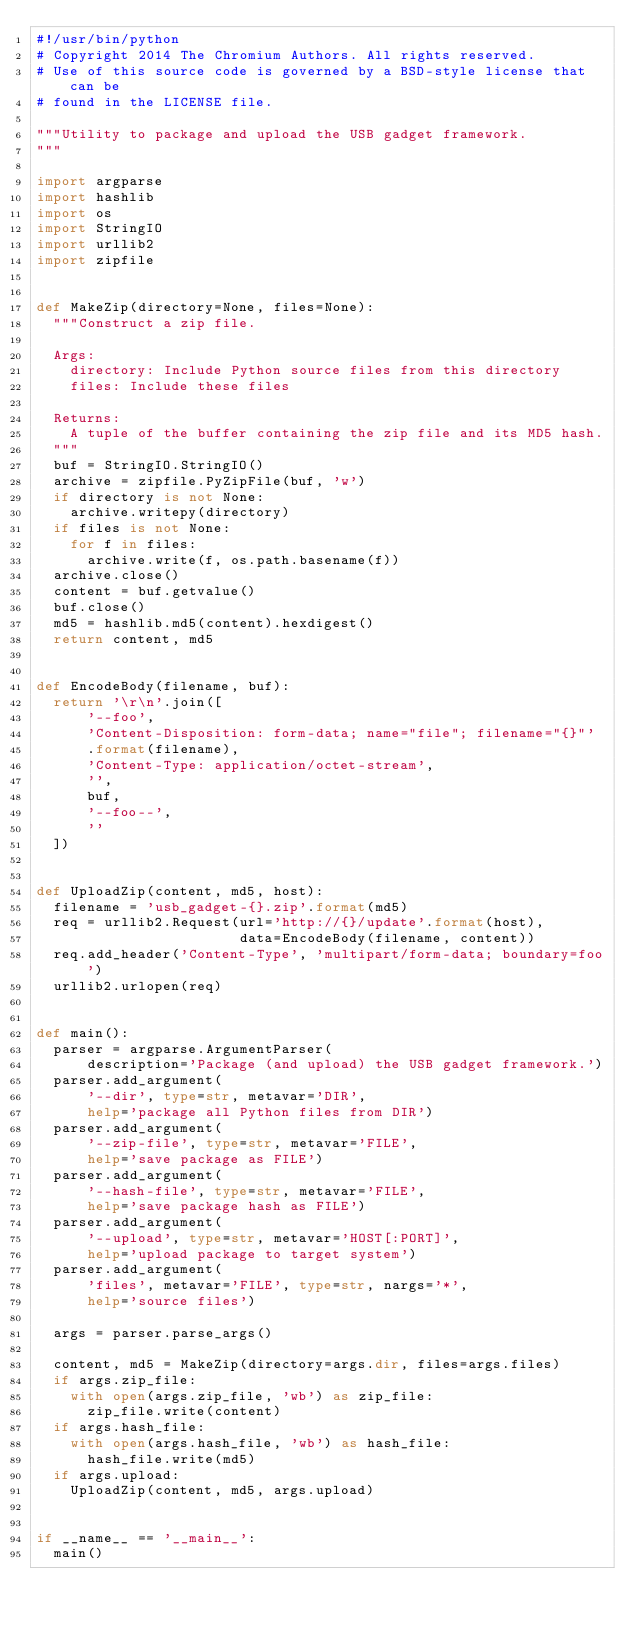Convert code to text. <code><loc_0><loc_0><loc_500><loc_500><_Python_>#!/usr/bin/python
# Copyright 2014 The Chromium Authors. All rights reserved.
# Use of this source code is governed by a BSD-style license that can be
# found in the LICENSE file.

"""Utility to package and upload the USB gadget framework.
"""

import argparse
import hashlib
import os
import StringIO
import urllib2
import zipfile


def MakeZip(directory=None, files=None):
  """Construct a zip file.

  Args:
    directory: Include Python source files from this directory
    files: Include these files

  Returns:
    A tuple of the buffer containing the zip file and its MD5 hash.
  """
  buf = StringIO.StringIO()
  archive = zipfile.PyZipFile(buf, 'w')
  if directory is not None:
    archive.writepy(directory)
  if files is not None:
    for f in files:
      archive.write(f, os.path.basename(f))
  archive.close()
  content = buf.getvalue()
  buf.close()
  md5 = hashlib.md5(content).hexdigest()
  return content, md5


def EncodeBody(filename, buf):
  return '\r\n'.join([
      '--foo',
      'Content-Disposition: form-data; name="file"; filename="{}"'
      .format(filename),
      'Content-Type: application/octet-stream',
      '',
      buf,
      '--foo--',
      ''
  ])


def UploadZip(content, md5, host):
  filename = 'usb_gadget-{}.zip'.format(md5)
  req = urllib2.Request(url='http://{}/update'.format(host),
                        data=EncodeBody(filename, content))
  req.add_header('Content-Type', 'multipart/form-data; boundary=foo')
  urllib2.urlopen(req)


def main():
  parser = argparse.ArgumentParser(
      description='Package (and upload) the USB gadget framework.')
  parser.add_argument(
      '--dir', type=str, metavar='DIR',
      help='package all Python files from DIR')
  parser.add_argument(
      '--zip-file', type=str, metavar='FILE',
      help='save package as FILE')
  parser.add_argument(
      '--hash-file', type=str, metavar='FILE',
      help='save package hash as FILE')
  parser.add_argument(
      '--upload', type=str, metavar='HOST[:PORT]',
      help='upload package to target system')
  parser.add_argument(
      'files', metavar='FILE', type=str, nargs='*',
      help='source files')

  args = parser.parse_args()

  content, md5 = MakeZip(directory=args.dir, files=args.files)
  if args.zip_file:
    with open(args.zip_file, 'wb') as zip_file:
      zip_file.write(content)
  if args.hash_file:
    with open(args.hash_file, 'wb') as hash_file:
      hash_file.write(md5)
  if args.upload:
    UploadZip(content, md5, args.upload)


if __name__ == '__main__':
  main()
</code> 